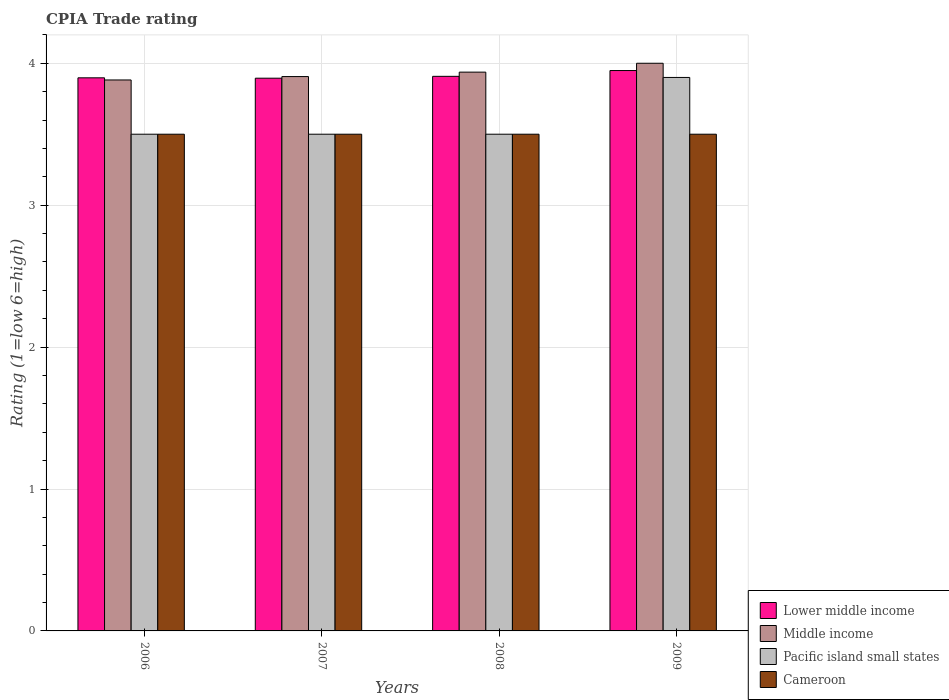How many different coloured bars are there?
Your answer should be compact. 4. How many groups of bars are there?
Ensure brevity in your answer.  4. Are the number of bars per tick equal to the number of legend labels?
Offer a terse response. Yes. How many bars are there on the 1st tick from the left?
Offer a terse response. 4. In how many cases, is the number of bars for a given year not equal to the number of legend labels?
Your answer should be very brief. 0. Across all years, what is the minimum CPIA rating in Pacific island small states?
Offer a terse response. 3.5. What is the total CPIA rating in Pacific island small states in the graph?
Your answer should be very brief. 14.4. What is the difference between the CPIA rating in Cameroon in 2008 and the CPIA rating in Middle income in 2007?
Provide a short and direct response. -0.41. What is the average CPIA rating in Middle income per year?
Provide a short and direct response. 3.93. In the year 2008, what is the difference between the CPIA rating in Cameroon and CPIA rating in Middle income?
Provide a succinct answer. -0.44. In how many years, is the CPIA rating in Cameroon greater than 0.8?
Your answer should be compact. 4. What is the ratio of the CPIA rating in Pacific island small states in 2007 to that in 2009?
Offer a very short reply. 0.9. Is the difference between the CPIA rating in Cameroon in 2006 and 2009 greater than the difference between the CPIA rating in Middle income in 2006 and 2009?
Offer a terse response. Yes. What is the difference between the highest and the second highest CPIA rating in Middle income?
Provide a short and direct response. 0.06. What is the difference between the highest and the lowest CPIA rating in Lower middle income?
Give a very brief answer. 0.05. In how many years, is the CPIA rating in Middle income greater than the average CPIA rating in Middle income taken over all years?
Keep it short and to the point. 2. Is the sum of the CPIA rating in Middle income in 2006 and 2009 greater than the maximum CPIA rating in Cameroon across all years?
Provide a succinct answer. Yes. What does the 3rd bar from the left in 2009 represents?
Provide a short and direct response. Pacific island small states. What does the 4th bar from the right in 2006 represents?
Provide a short and direct response. Lower middle income. Is it the case that in every year, the sum of the CPIA rating in Pacific island small states and CPIA rating in Lower middle income is greater than the CPIA rating in Cameroon?
Your answer should be very brief. Yes. Are all the bars in the graph horizontal?
Give a very brief answer. No. Are the values on the major ticks of Y-axis written in scientific E-notation?
Provide a short and direct response. No. Does the graph contain grids?
Your response must be concise. Yes. Where does the legend appear in the graph?
Ensure brevity in your answer.  Bottom right. What is the title of the graph?
Your answer should be compact. CPIA Trade rating. What is the label or title of the X-axis?
Provide a succinct answer. Years. What is the label or title of the Y-axis?
Offer a terse response. Rating (1=low 6=high). What is the Rating (1=low 6=high) of Lower middle income in 2006?
Give a very brief answer. 3.9. What is the Rating (1=low 6=high) of Middle income in 2006?
Keep it short and to the point. 3.88. What is the Rating (1=low 6=high) in Cameroon in 2006?
Your answer should be compact. 3.5. What is the Rating (1=low 6=high) of Lower middle income in 2007?
Give a very brief answer. 3.89. What is the Rating (1=low 6=high) in Middle income in 2007?
Provide a short and direct response. 3.91. What is the Rating (1=low 6=high) in Cameroon in 2007?
Your answer should be compact. 3.5. What is the Rating (1=low 6=high) of Lower middle income in 2008?
Provide a succinct answer. 3.91. What is the Rating (1=low 6=high) of Middle income in 2008?
Your answer should be very brief. 3.94. What is the Rating (1=low 6=high) of Pacific island small states in 2008?
Offer a very short reply. 3.5. What is the Rating (1=low 6=high) in Cameroon in 2008?
Give a very brief answer. 3.5. What is the Rating (1=low 6=high) of Lower middle income in 2009?
Keep it short and to the point. 3.95. What is the Rating (1=low 6=high) in Pacific island small states in 2009?
Your response must be concise. 3.9. Across all years, what is the maximum Rating (1=low 6=high) of Lower middle income?
Provide a succinct answer. 3.95. Across all years, what is the maximum Rating (1=low 6=high) in Cameroon?
Your answer should be very brief. 3.5. Across all years, what is the minimum Rating (1=low 6=high) of Lower middle income?
Keep it short and to the point. 3.89. Across all years, what is the minimum Rating (1=low 6=high) of Middle income?
Give a very brief answer. 3.88. What is the total Rating (1=low 6=high) in Lower middle income in the graph?
Provide a short and direct response. 15.65. What is the total Rating (1=low 6=high) of Middle income in the graph?
Provide a succinct answer. 15.73. What is the total Rating (1=low 6=high) of Cameroon in the graph?
Your answer should be very brief. 14. What is the difference between the Rating (1=low 6=high) of Lower middle income in 2006 and that in 2007?
Your answer should be compact. 0. What is the difference between the Rating (1=low 6=high) of Middle income in 2006 and that in 2007?
Your answer should be compact. -0.02. What is the difference between the Rating (1=low 6=high) of Pacific island small states in 2006 and that in 2007?
Your answer should be compact. 0. What is the difference between the Rating (1=low 6=high) of Lower middle income in 2006 and that in 2008?
Your answer should be very brief. -0.01. What is the difference between the Rating (1=low 6=high) of Middle income in 2006 and that in 2008?
Provide a succinct answer. -0.06. What is the difference between the Rating (1=low 6=high) in Lower middle income in 2006 and that in 2009?
Ensure brevity in your answer.  -0.05. What is the difference between the Rating (1=low 6=high) in Middle income in 2006 and that in 2009?
Provide a short and direct response. -0.12. What is the difference between the Rating (1=low 6=high) of Pacific island small states in 2006 and that in 2009?
Offer a terse response. -0.4. What is the difference between the Rating (1=low 6=high) in Lower middle income in 2007 and that in 2008?
Provide a succinct answer. -0.01. What is the difference between the Rating (1=low 6=high) in Middle income in 2007 and that in 2008?
Provide a short and direct response. -0.03. What is the difference between the Rating (1=low 6=high) in Pacific island small states in 2007 and that in 2008?
Your answer should be very brief. 0. What is the difference between the Rating (1=low 6=high) in Cameroon in 2007 and that in 2008?
Keep it short and to the point. 0. What is the difference between the Rating (1=low 6=high) in Lower middle income in 2007 and that in 2009?
Make the answer very short. -0.05. What is the difference between the Rating (1=low 6=high) in Middle income in 2007 and that in 2009?
Give a very brief answer. -0.09. What is the difference between the Rating (1=low 6=high) in Lower middle income in 2008 and that in 2009?
Your answer should be compact. -0.04. What is the difference between the Rating (1=low 6=high) in Middle income in 2008 and that in 2009?
Ensure brevity in your answer.  -0.06. What is the difference between the Rating (1=low 6=high) of Cameroon in 2008 and that in 2009?
Your answer should be compact. 0. What is the difference between the Rating (1=low 6=high) in Lower middle income in 2006 and the Rating (1=low 6=high) in Middle income in 2007?
Your answer should be very brief. -0.01. What is the difference between the Rating (1=low 6=high) in Lower middle income in 2006 and the Rating (1=low 6=high) in Pacific island small states in 2007?
Provide a succinct answer. 0.4. What is the difference between the Rating (1=low 6=high) in Lower middle income in 2006 and the Rating (1=low 6=high) in Cameroon in 2007?
Your answer should be compact. 0.4. What is the difference between the Rating (1=low 6=high) in Middle income in 2006 and the Rating (1=low 6=high) in Pacific island small states in 2007?
Offer a terse response. 0.38. What is the difference between the Rating (1=low 6=high) of Middle income in 2006 and the Rating (1=low 6=high) of Cameroon in 2007?
Provide a short and direct response. 0.38. What is the difference between the Rating (1=low 6=high) in Lower middle income in 2006 and the Rating (1=low 6=high) in Middle income in 2008?
Give a very brief answer. -0.04. What is the difference between the Rating (1=low 6=high) of Lower middle income in 2006 and the Rating (1=low 6=high) of Pacific island small states in 2008?
Your response must be concise. 0.4. What is the difference between the Rating (1=low 6=high) in Lower middle income in 2006 and the Rating (1=low 6=high) in Cameroon in 2008?
Your answer should be very brief. 0.4. What is the difference between the Rating (1=low 6=high) in Middle income in 2006 and the Rating (1=low 6=high) in Pacific island small states in 2008?
Give a very brief answer. 0.38. What is the difference between the Rating (1=low 6=high) in Middle income in 2006 and the Rating (1=low 6=high) in Cameroon in 2008?
Offer a very short reply. 0.38. What is the difference between the Rating (1=low 6=high) of Lower middle income in 2006 and the Rating (1=low 6=high) of Middle income in 2009?
Keep it short and to the point. -0.1. What is the difference between the Rating (1=low 6=high) in Lower middle income in 2006 and the Rating (1=low 6=high) in Pacific island small states in 2009?
Your response must be concise. -0. What is the difference between the Rating (1=low 6=high) of Lower middle income in 2006 and the Rating (1=low 6=high) of Cameroon in 2009?
Provide a succinct answer. 0.4. What is the difference between the Rating (1=low 6=high) in Middle income in 2006 and the Rating (1=low 6=high) in Pacific island small states in 2009?
Make the answer very short. -0.02. What is the difference between the Rating (1=low 6=high) in Middle income in 2006 and the Rating (1=low 6=high) in Cameroon in 2009?
Your response must be concise. 0.38. What is the difference between the Rating (1=low 6=high) of Pacific island small states in 2006 and the Rating (1=low 6=high) of Cameroon in 2009?
Ensure brevity in your answer.  0. What is the difference between the Rating (1=low 6=high) of Lower middle income in 2007 and the Rating (1=low 6=high) of Middle income in 2008?
Ensure brevity in your answer.  -0.04. What is the difference between the Rating (1=low 6=high) in Lower middle income in 2007 and the Rating (1=low 6=high) in Pacific island small states in 2008?
Provide a short and direct response. 0.39. What is the difference between the Rating (1=low 6=high) of Lower middle income in 2007 and the Rating (1=low 6=high) of Cameroon in 2008?
Provide a succinct answer. 0.39. What is the difference between the Rating (1=low 6=high) of Middle income in 2007 and the Rating (1=low 6=high) of Pacific island small states in 2008?
Keep it short and to the point. 0.41. What is the difference between the Rating (1=low 6=high) in Middle income in 2007 and the Rating (1=low 6=high) in Cameroon in 2008?
Give a very brief answer. 0.41. What is the difference between the Rating (1=low 6=high) of Pacific island small states in 2007 and the Rating (1=low 6=high) of Cameroon in 2008?
Your answer should be compact. 0. What is the difference between the Rating (1=low 6=high) of Lower middle income in 2007 and the Rating (1=low 6=high) of Middle income in 2009?
Your answer should be very brief. -0.11. What is the difference between the Rating (1=low 6=high) in Lower middle income in 2007 and the Rating (1=low 6=high) in Pacific island small states in 2009?
Your response must be concise. -0.01. What is the difference between the Rating (1=low 6=high) of Lower middle income in 2007 and the Rating (1=low 6=high) of Cameroon in 2009?
Your answer should be compact. 0.39. What is the difference between the Rating (1=low 6=high) of Middle income in 2007 and the Rating (1=low 6=high) of Pacific island small states in 2009?
Make the answer very short. 0.01. What is the difference between the Rating (1=low 6=high) of Middle income in 2007 and the Rating (1=low 6=high) of Cameroon in 2009?
Give a very brief answer. 0.41. What is the difference between the Rating (1=low 6=high) in Pacific island small states in 2007 and the Rating (1=low 6=high) in Cameroon in 2009?
Provide a succinct answer. 0. What is the difference between the Rating (1=low 6=high) in Lower middle income in 2008 and the Rating (1=low 6=high) in Middle income in 2009?
Your response must be concise. -0.09. What is the difference between the Rating (1=low 6=high) in Lower middle income in 2008 and the Rating (1=low 6=high) in Pacific island small states in 2009?
Offer a very short reply. 0.01. What is the difference between the Rating (1=low 6=high) in Lower middle income in 2008 and the Rating (1=low 6=high) in Cameroon in 2009?
Ensure brevity in your answer.  0.41. What is the difference between the Rating (1=low 6=high) in Middle income in 2008 and the Rating (1=low 6=high) in Pacific island small states in 2009?
Make the answer very short. 0.04. What is the difference between the Rating (1=low 6=high) in Middle income in 2008 and the Rating (1=low 6=high) in Cameroon in 2009?
Provide a short and direct response. 0.44. What is the difference between the Rating (1=low 6=high) in Pacific island small states in 2008 and the Rating (1=low 6=high) in Cameroon in 2009?
Offer a very short reply. 0. What is the average Rating (1=low 6=high) in Lower middle income per year?
Give a very brief answer. 3.91. What is the average Rating (1=low 6=high) in Middle income per year?
Offer a very short reply. 3.93. What is the average Rating (1=low 6=high) in Cameroon per year?
Keep it short and to the point. 3.5. In the year 2006, what is the difference between the Rating (1=low 6=high) in Lower middle income and Rating (1=low 6=high) in Middle income?
Offer a terse response. 0.02. In the year 2006, what is the difference between the Rating (1=low 6=high) of Lower middle income and Rating (1=low 6=high) of Pacific island small states?
Provide a succinct answer. 0.4. In the year 2006, what is the difference between the Rating (1=low 6=high) of Lower middle income and Rating (1=low 6=high) of Cameroon?
Offer a very short reply. 0.4. In the year 2006, what is the difference between the Rating (1=low 6=high) of Middle income and Rating (1=low 6=high) of Pacific island small states?
Make the answer very short. 0.38. In the year 2006, what is the difference between the Rating (1=low 6=high) in Middle income and Rating (1=low 6=high) in Cameroon?
Give a very brief answer. 0.38. In the year 2007, what is the difference between the Rating (1=low 6=high) in Lower middle income and Rating (1=low 6=high) in Middle income?
Provide a short and direct response. -0.01. In the year 2007, what is the difference between the Rating (1=low 6=high) in Lower middle income and Rating (1=low 6=high) in Pacific island small states?
Provide a succinct answer. 0.39. In the year 2007, what is the difference between the Rating (1=low 6=high) in Lower middle income and Rating (1=low 6=high) in Cameroon?
Your answer should be very brief. 0.39. In the year 2007, what is the difference between the Rating (1=low 6=high) in Middle income and Rating (1=low 6=high) in Pacific island small states?
Make the answer very short. 0.41. In the year 2007, what is the difference between the Rating (1=low 6=high) of Middle income and Rating (1=low 6=high) of Cameroon?
Your answer should be compact. 0.41. In the year 2007, what is the difference between the Rating (1=low 6=high) of Pacific island small states and Rating (1=low 6=high) of Cameroon?
Your answer should be very brief. 0. In the year 2008, what is the difference between the Rating (1=low 6=high) of Lower middle income and Rating (1=low 6=high) of Middle income?
Give a very brief answer. -0.03. In the year 2008, what is the difference between the Rating (1=low 6=high) in Lower middle income and Rating (1=low 6=high) in Pacific island small states?
Your answer should be very brief. 0.41. In the year 2008, what is the difference between the Rating (1=low 6=high) of Lower middle income and Rating (1=low 6=high) of Cameroon?
Ensure brevity in your answer.  0.41. In the year 2008, what is the difference between the Rating (1=low 6=high) of Middle income and Rating (1=low 6=high) of Pacific island small states?
Keep it short and to the point. 0.44. In the year 2008, what is the difference between the Rating (1=low 6=high) of Middle income and Rating (1=low 6=high) of Cameroon?
Ensure brevity in your answer.  0.44. In the year 2009, what is the difference between the Rating (1=low 6=high) of Lower middle income and Rating (1=low 6=high) of Middle income?
Your response must be concise. -0.05. In the year 2009, what is the difference between the Rating (1=low 6=high) in Lower middle income and Rating (1=low 6=high) in Pacific island small states?
Keep it short and to the point. 0.05. In the year 2009, what is the difference between the Rating (1=low 6=high) in Lower middle income and Rating (1=low 6=high) in Cameroon?
Provide a succinct answer. 0.45. In the year 2009, what is the difference between the Rating (1=low 6=high) of Middle income and Rating (1=low 6=high) of Pacific island small states?
Give a very brief answer. 0.1. What is the ratio of the Rating (1=low 6=high) of Lower middle income in 2006 to that in 2007?
Offer a very short reply. 1. What is the ratio of the Rating (1=low 6=high) in Pacific island small states in 2006 to that in 2007?
Offer a very short reply. 1. What is the ratio of the Rating (1=low 6=high) in Middle income in 2006 to that in 2008?
Provide a short and direct response. 0.99. What is the ratio of the Rating (1=low 6=high) of Cameroon in 2006 to that in 2008?
Ensure brevity in your answer.  1. What is the ratio of the Rating (1=low 6=high) in Middle income in 2006 to that in 2009?
Provide a short and direct response. 0.97. What is the ratio of the Rating (1=low 6=high) in Pacific island small states in 2006 to that in 2009?
Your response must be concise. 0.9. What is the ratio of the Rating (1=low 6=high) of Middle income in 2007 to that in 2008?
Keep it short and to the point. 0.99. What is the ratio of the Rating (1=low 6=high) in Pacific island small states in 2007 to that in 2008?
Offer a terse response. 1. What is the ratio of the Rating (1=low 6=high) in Cameroon in 2007 to that in 2008?
Your response must be concise. 1. What is the ratio of the Rating (1=low 6=high) of Lower middle income in 2007 to that in 2009?
Your answer should be compact. 0.99. What is the ratio of the Rating (1=low 6=high) in Middle income in 2007 to that in 2009?
Your answer should be very brief. 0.98. What is the ratio of the Rating (1=low 6=high) in Pacific island small states in 2007 to that in 2009?
Provide a succinct answer. 0.9. What is the ratio of the Rating (1=low 6=high) in Middle income in 2008 to that in 2009?
Offer a very short reply. 0.98. What is the ratio of the Rating (1=low 6=high) of Pacific island small states in 2008 to that in 2009?
Offer a very short reply. 0.9. What is the ratio of the Rating (1=low 6=high) of Cameroon in 2008 to that in 2009?
Give a very brief answer. 1. What is the difference between the highest and the second highest Rating (1=low 6=high) in Lower middle income?
Keep it short and to the point. 0.04. What is the difference between the highest and the second highest Rating (1=low 6=high) in Middle income?
Your answer should be very brief. 0.06. What is the difference between the highest and the second highest Rating (1=low 6=high) of Pacific island small states?
Ensure brevity in your answer.  0.4. What is the difference between the highest and the lowest Rating (1=low 6=high) of Lower middle income?
Your answer should be very brief. 0.05. What is the difference between the highest and the lowest Rating (1=low 6=high) of Middle income?
Provide a short and direct response. 0.12. What is the difference between the highest and the lowest Rating (1=low 6=high) in Pacific island small states?
Your response must be concise. 0.4. What is the difference between the highest and the lowest Rating (1=low 6=high) in Cameroon?
Your answer should be compact. 0. 